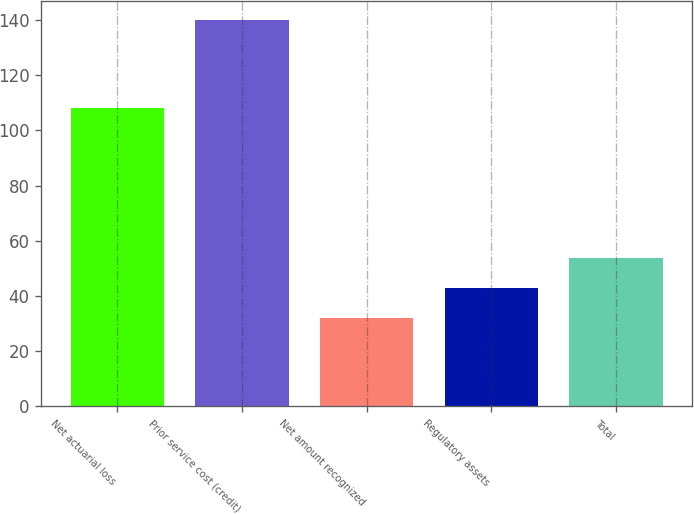<chart> <loc_0><loc_0><loc_500><loc_500><bar_chart><fcel>Net actuarial loss<fcel>Prior service cost (credit)<fcel>Net amount recognized<fcel>Regulatory assets<fcel>Total<nl><fcel>108<fcel>140<fcel>32<fcel>42.8<fcel>53.6<nl></chart> 